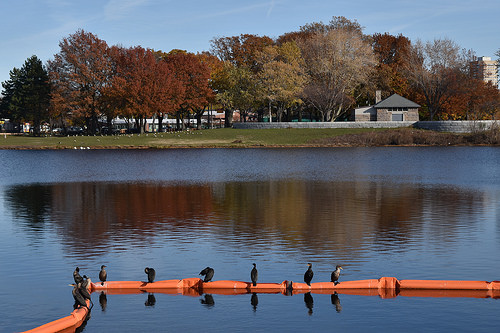<image>
Is the bird above the water? Yes. The bird is positioned above the water in the vertical space, higher up in the scene. 